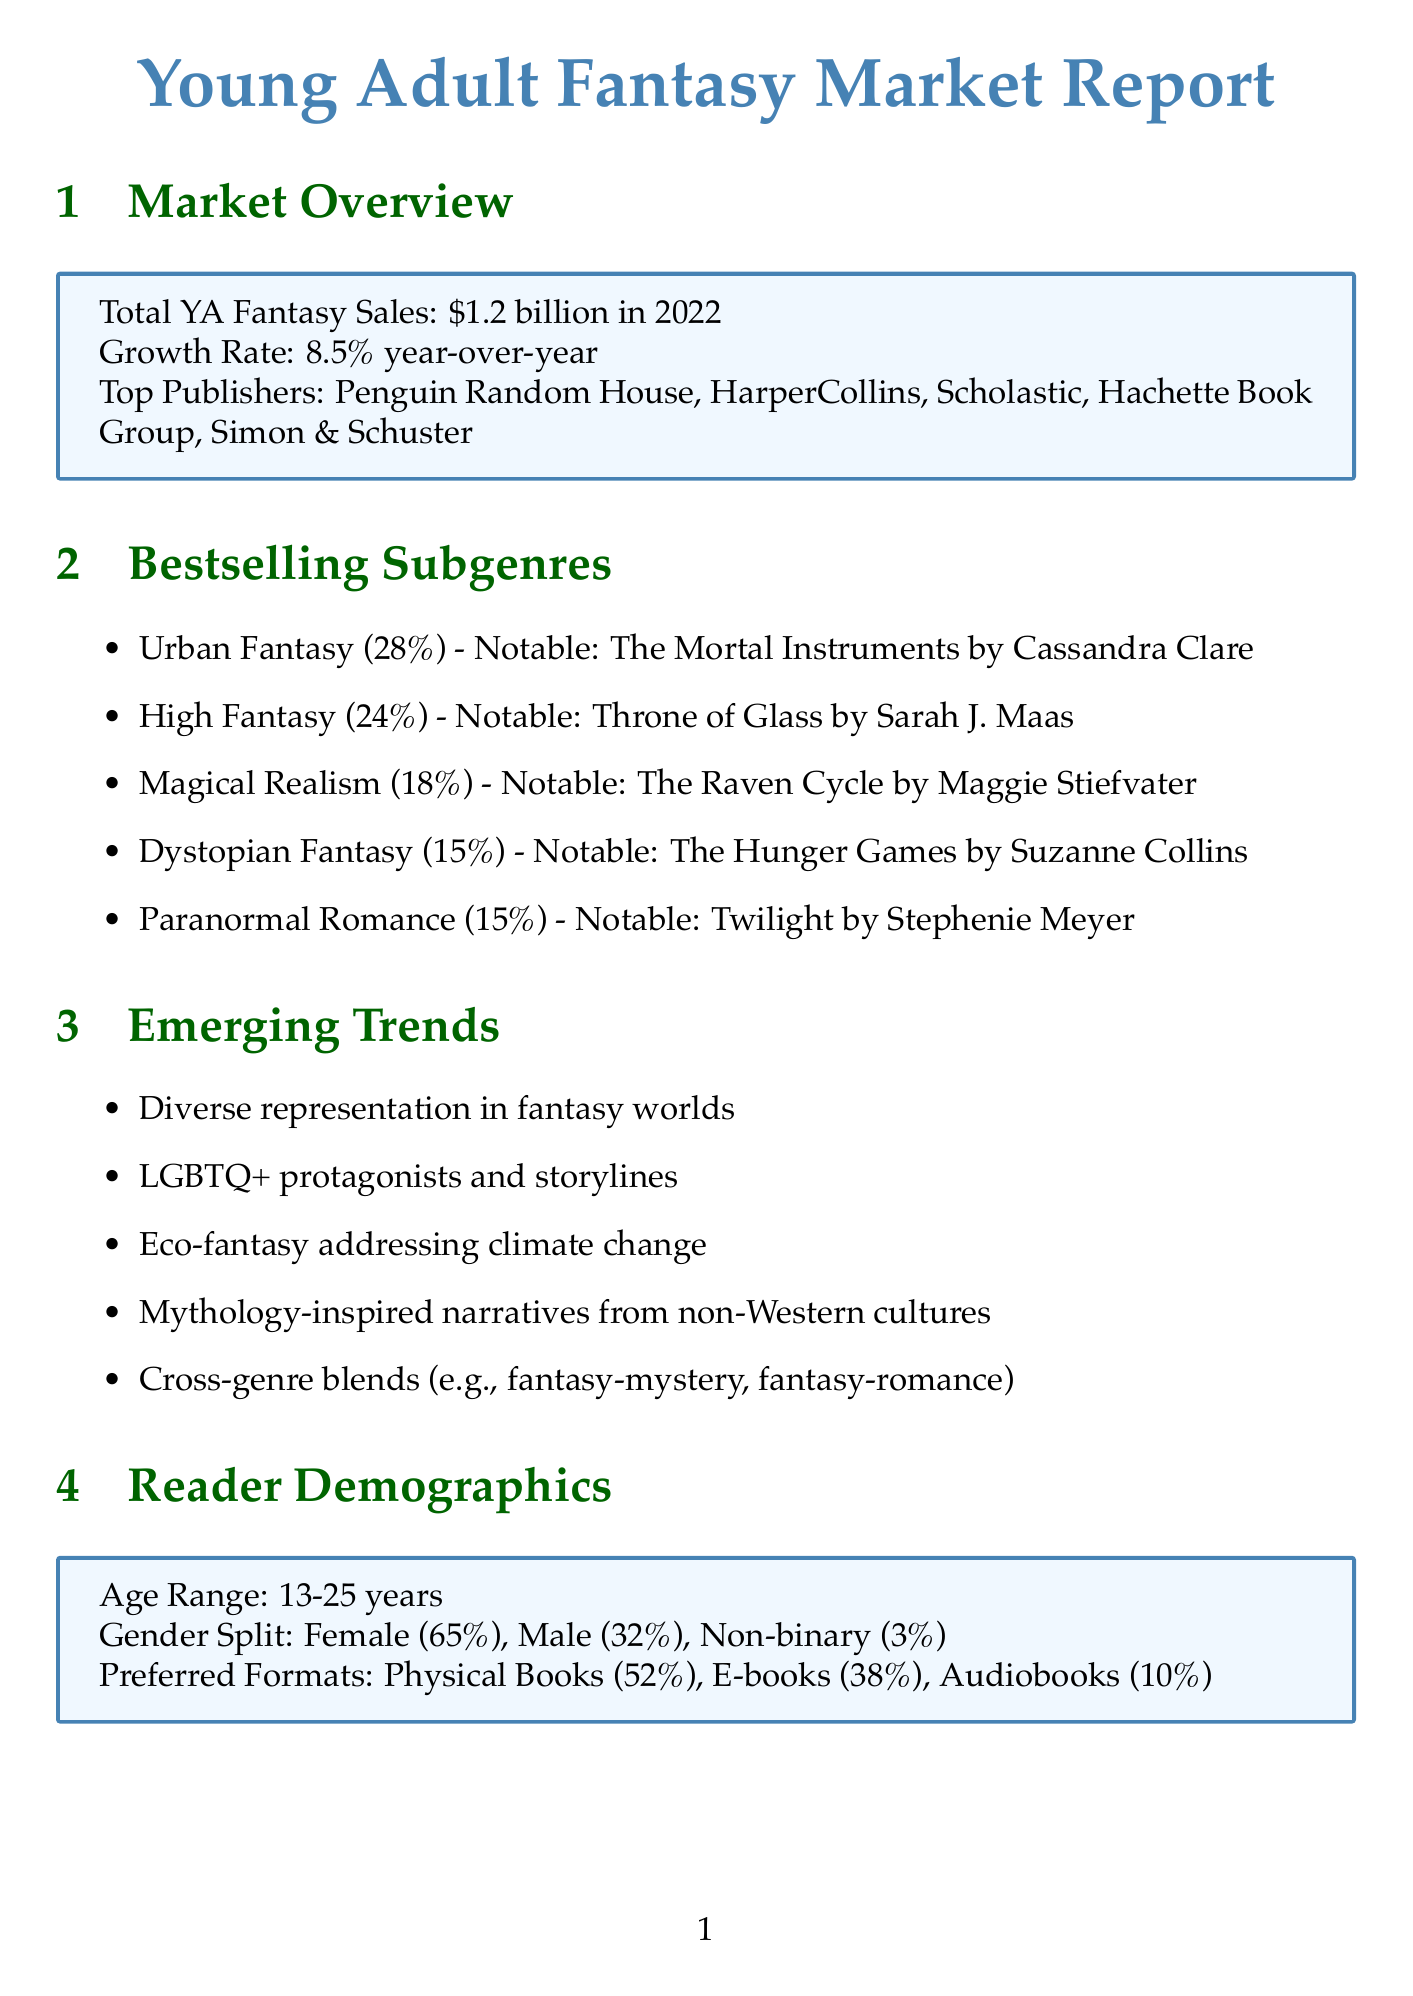what was the total YA fantasy sales in 2022? The total YA fantasy sales in 2022 is specified in the market overview section of the document.
Answer: $1.2 billion what is the year-over-year growth rate? The year-over-year growth rate is mentioned in the market overview section, indicating how much the market has increased.
Answer: 8.5% year-over-year which publisher has the highest market share? The top publishers are listed in order in the market overview, allowing us to identify the first one as the highest.
Answer: Penguin Random House what percentage of the market does Urban Fantasy represent? The market share for Urban Fantasy is included in the bestselling subgenres section.
Answer: 28% name a notable series in High Fantasy. The document provides notable series for each subgenre, including High Fantasy.
Answer: Throne of Glass by Sarah J. Maas what is the age range of the primary reader demographic? The document specifies the age range of readers in the demographics section, indicating the target audience.
Answer: 13-25 years what marketing platform is noted for high effectiveness? The marketing channels section highlights different platforms, stating their effectiveness levels.
Answer: BookTok (TikTok) what is an emerging trend in YA fantasy? The document lists several emerging trends, indicating new directions in the genre.
Answer: Diverse representation in fantasy worlds how much is the expected annual growth for the next five years? Future projections in the report indicate expected growth rates for the industry.
Answer: 6-7% annually name a notable upcoming adaptation mentioned in the document. The future projections section lists upcoming adaptations of popular works.
Answer: Shadow and Bone (Netflix) 